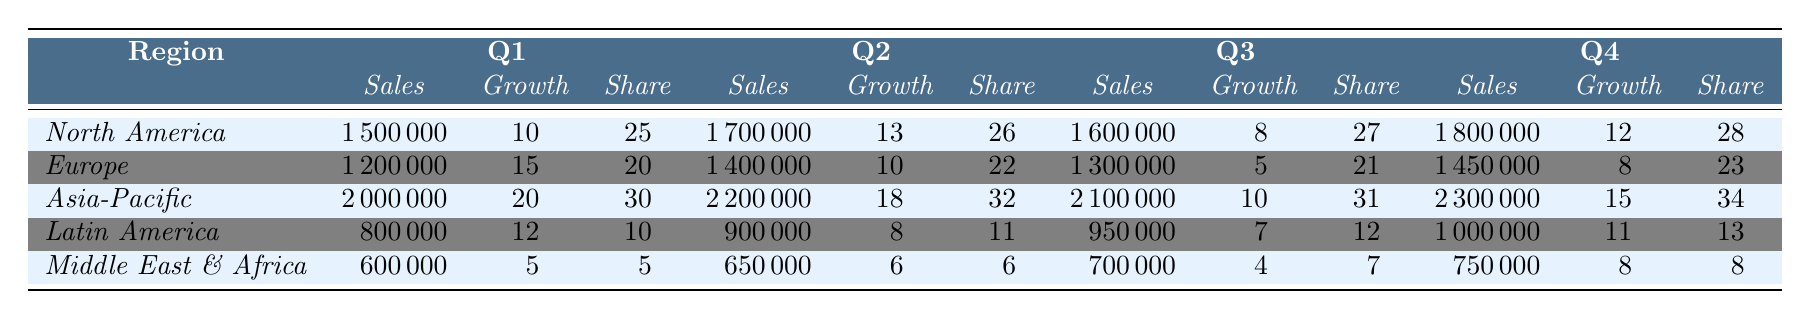What was the total sales in North America for Q4? The total sales in North America for Q4 is provided in the table. It shows that the sales for Q4 are 1,800,000.
Answer: 1,800,000 Which region had the highest market share in Q3? From the table, we check the market share values for Q3: North America is 27, Europe is 21, Asia-Pacific is 31, Latin America is 12, and Middle East & Africa is 7. The highest is Asia-Pacific with a market share of 31.
Answer: Asia-Pacific What is the average sales across all regions in Q2? We calculate the average sales for Q2 by adding the sales values: 1,700,000 (North America) + 1,400,000 (Europe) + 2,200,000 (Asia-Pacific) + 900,000 (Latin America) + 650,000 (Middle East & Africa) = 6,850,000. Then, we divide this by the number of regions (5): 6,850,000 / 5 = 1,370,000.
Answer: 1,370,000 Did Latin America experience a decrease in sales from Q2 to Q3? Looking at the table, for Latin America, Q2 sales are 900,000 and Q3 sales are 950,000. Since 950,000 is greater than 900,000, it indicates an increase.
Answer: No What was the total sales growth percentage for Europe in the year? We sum the annual growth percentages for Europe from Q1 (15), Q2 (10), Q3 (5), and Q4 (8): 15 + 10 + 5 + 8 = 38.
Answer: 38 Which quarter showed the lowest sales for Middle East & Africa? The table provides quarterly sales data for Middle East & Africa: Q1 is 600,000, Q2 is 650,000, Q3 is 700,000, and Q4 is 750,000. The lowest sales occurred in Q1 with 600,000.
Answer: Q1 What is the percentage increase in sales for Asia-Pacific from Q1 to Q4? Asia-Pacific had sales of 2,000,000 in Q1 and 2,300,000 in Q4. The increase is calculated as (2,300,000 - 2,000,000) / 2,000,000 * 100 = 15%.
Answer: 15% Between which two quarters did Europe experience the largest drop in growth percentage? The growth percentages for Europe are: Q1 (15), Q2 (10), Q3 (5), and Q4 (8). The largest drop is from Q1 to Q3: 15 to 5, which is a drop of 10.
Answer: Q1 to Q3 